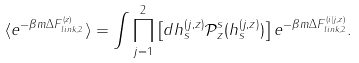<formula> <loc_0><loc_0><loc_500><loc_500>\langle e ^ { - \beta m \Delta F _ { l i n k , 2 } ^ { ( z ) } } \rangle = \int \prod _ { j = 1 } ^ { 2 } \left [ d h _ { s } ^ { ( j , z ) } \mathcal { P } _ { z } ^ { s } ( h _ { s } ^ { ( j , z ) } ) \right ] e ^ { - \beta m \Delta F _ { l i n k , 2 } ^ { ( i | j , z ) } } .</formula> 